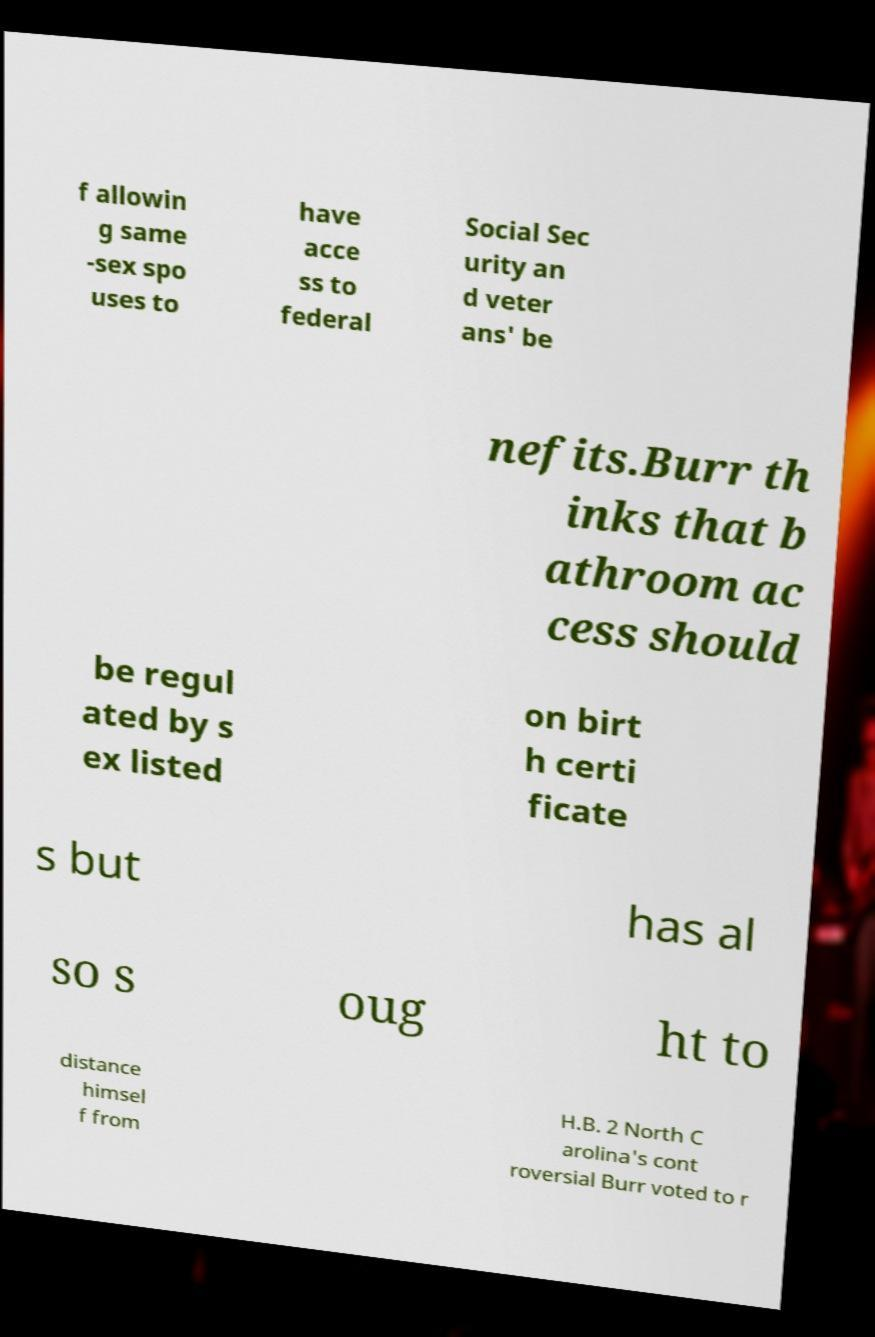What messages or text are displayed in this image? I need them in a readable, typed format. f allowin g same -sex spo uses to have acce ss to federal Social Sec urity an d veter ans' be nefits.Burr th inks that b athroom ac cess should be regul ated by s ex listed on birt h certi ficate s but has al so s oug ht to distance himsel f from H.B. 2 North C arolina's cont roversial Burr voted to r 